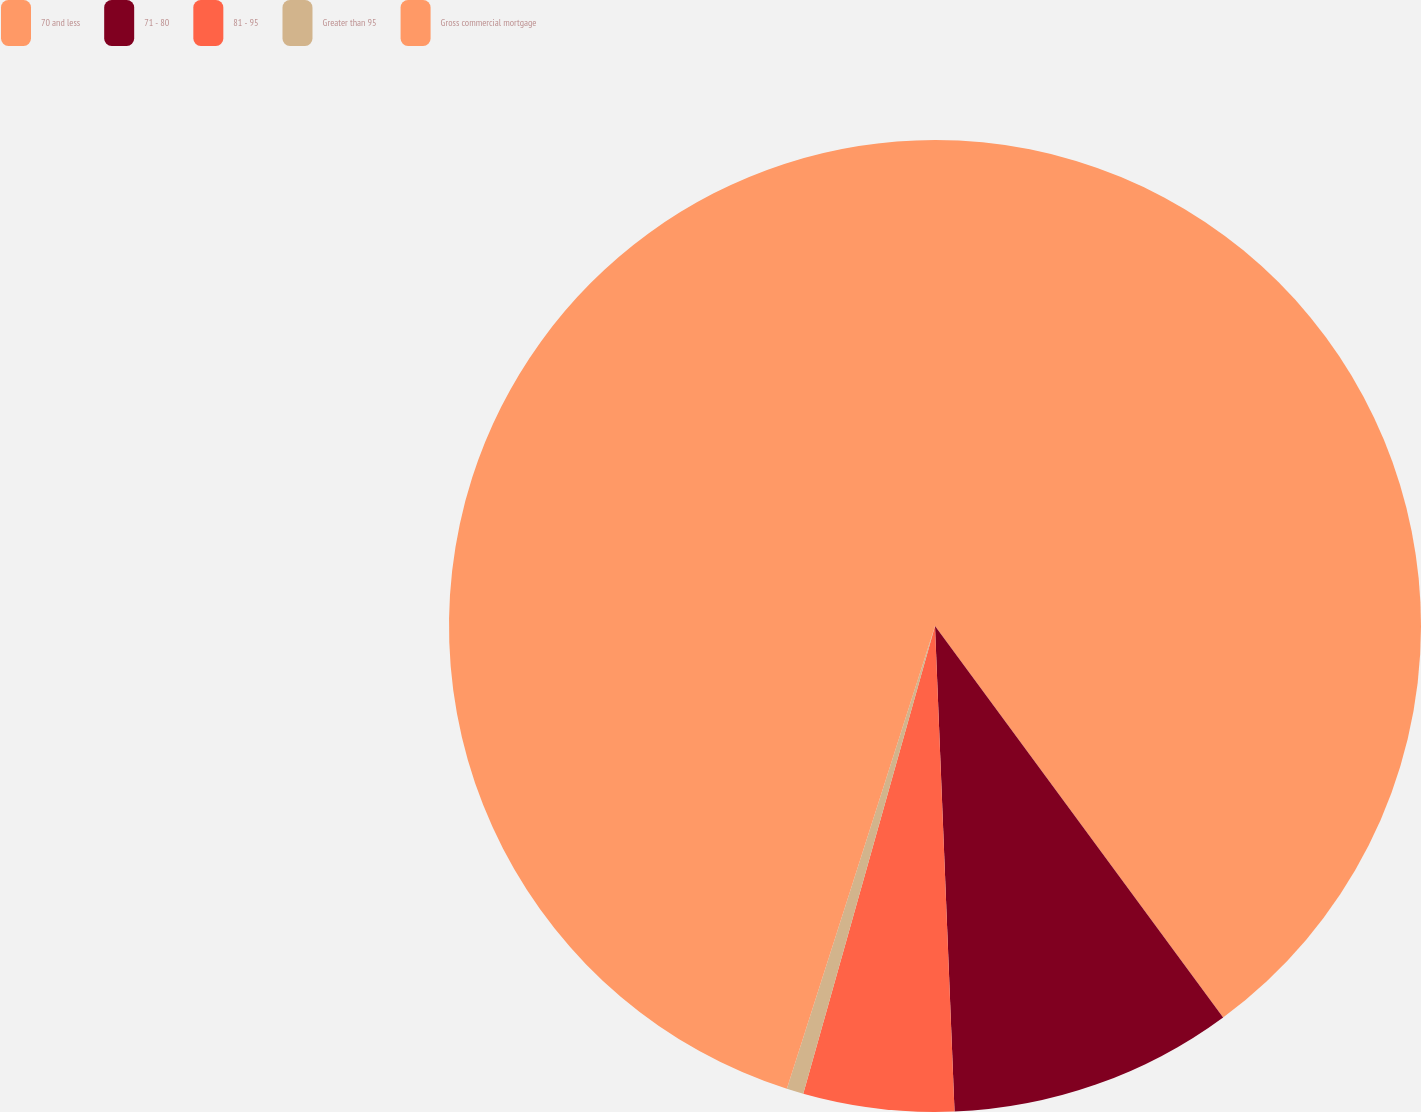Convert chart to OTSL. <chart><loc_0><loc_0><loc_500><loc_500><pie_chart><fcel>70 and less<fcel>71 - 80<fcel>81 - 95<fcel>Greater than 95<fcel>Gross commercial mortgage<nl><fcel>39.9%<fcel>9.46%<fcel>5.01%<fcel>0.56%<fcel>45.07%<nl></chart> 